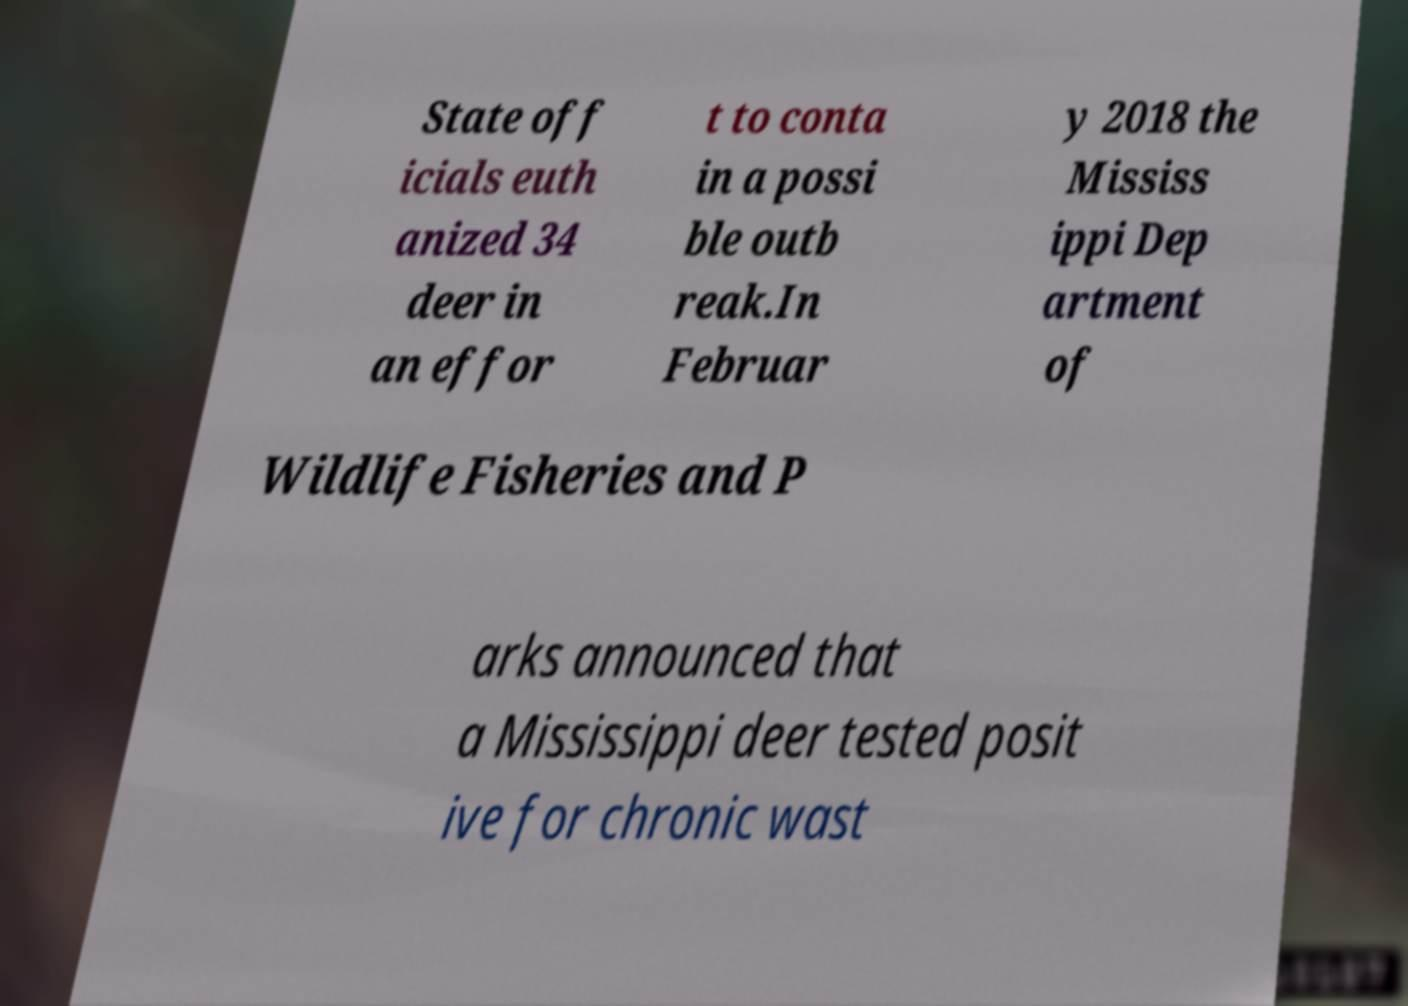Could you extract and type out the text from this image? State off icials euth anized 34 deer in an effor t to conta in a possi ble outb reak.In Februar y 2018 the Mississ ippi Dep artment of Wildlife Fisheries and P arks announced that a Mississippi deer tested posit ive for chronic wast 